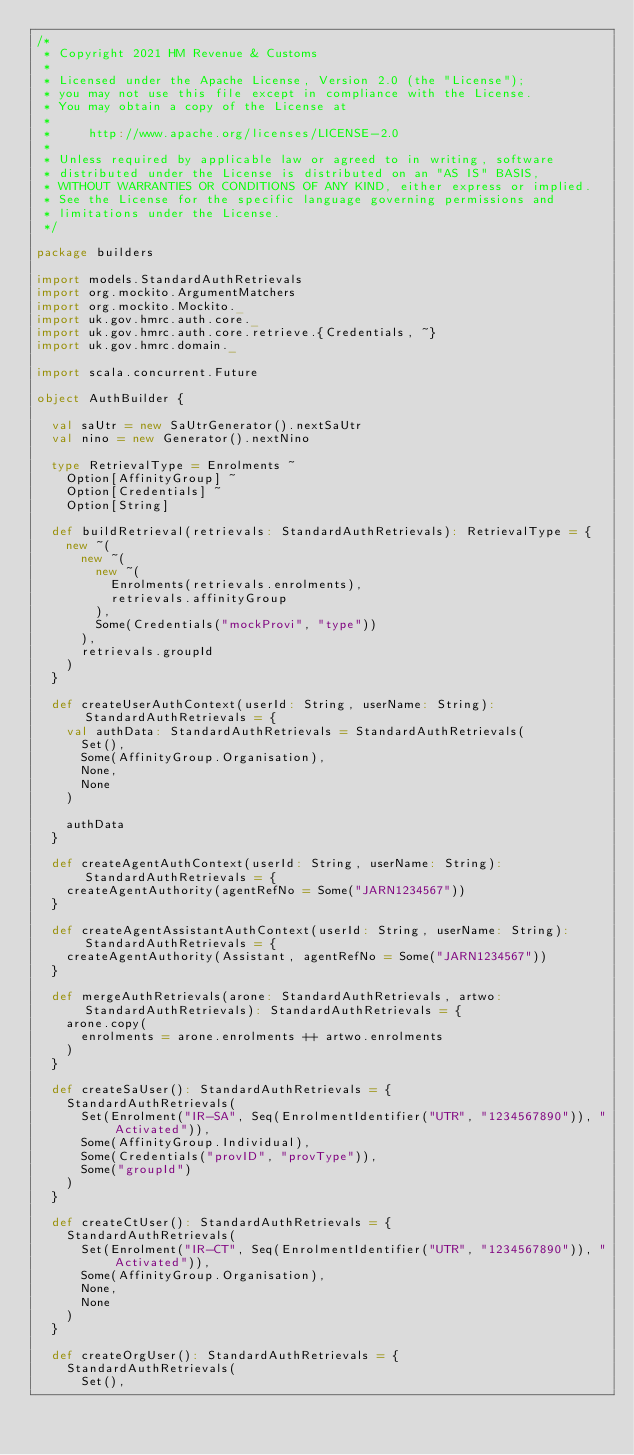Convert code to text. <code><loc_0><loc_0><loc_500><loc_500><_Scala_>/*
 * Copyright 2021 HM Revenue & Customs
 *
 * Licensed under the Apache License, Version 2.0 (the "License");
 * you may not use this file except in compliance with the License.
 * You may obtain a copy of the License at
 *
 *     http://www.apache.org/licenses/LICENSE-2.0
 *
 * Unless required by applicable law or agreed to in writing, software
 * distributed under the License is distributed on an "AS IS" BASIS,
 * WITHOUT WARRANTIES OR CONDITIONS OF ANY KIND, either express or implied.
 * See the License for the specific language governing permissions and
 * limitations under the License.
 */

package builders

import models.StandardAuthRetrievals
import org.mockito.ArgumentMatchers
import org.mockito.Mockito._
import uk.gov.hmrc.auth.core._
import uk.gov.hmrc.auth.core.retrieve.{Credentials, ~}
import uk.gov.hmrc.domain._

import scala.concurrent.Future

object AuthBuilder {

  val saUtr = new SaUtrGenerator().nextSaUtr
  val nino = new Generator().nextNino

  type RetrievalType = Enrolments ~
    Option[AffinityGroup] ~
    Option[Credentials] ~
    Option[String]

  def buildRetrieval(retrievals: StandardAuthRetrievals): RetrievalType = {
    new ~(
      new ~(
        new ~(
          Enrolments(retrievals.enrolments),
          retrievals.affinityGroup
        ),
        Some(Credentials("mockProvi", "type"))
      ),
      retrievals.groupId
    )
  }

  def createUserAuthContext(userId: String, userName: String): StandardAuthRetrievals = {
    val authData: StandardAuthRetrievals = StandardAuthRetrievals(
      Set(),
      Some(AffinityGroup.Organisation),
      None,
      None
    )

    authData
  }

  def createAgentAuthContext(userId: String, userName: String): StandardAuthRetrievals = {
    createAgentAuthority(agentRefNo = Some("JARN1234567"))
  }

  def createAgentAssistantAuthContext(userId: String, userName: String): StandardAuthRetrievals = {
    createAgentAuthority(Assistant, agentRefNo = Some("JARN1234567"))
  }

  def mergeAuthRetrievals(arone: StandardAuthRetrievals, artwo: StandardAuthRetrievals): StandardAuthRetrievals = {
    arone.copy(
      enrolments = arone.enrolments ++ artwo.enrolments
    )
  }

  def createSaUser(): StandardAuthRetrievals = {
    StandardAuthRetrievals(
      Set(Enrolment("IR-SA", Seq(EnrolmentIdentifier("UTR", "1234567890")), "Activated")),
      Some(AffinityGroup.Individual),
      Some(Credentials("provID", "provType")),
      Some("groupId")
    )
  }

  def createCtUser(): StandardAuthRetrievals = {
    StandardAuthRetrievals(
      Set(Enrolment("IR-CT", Seq(EnrolmentIdentifier("UTR", "1234567890")), "Activated")),
      Some(AffinityGroup.Organisation),
      None,
      None
    )
  }

  def createOrgUser(): StandardAuthRetrievals = {
    StandardAuthRetrievals(
      Set(),</code> 